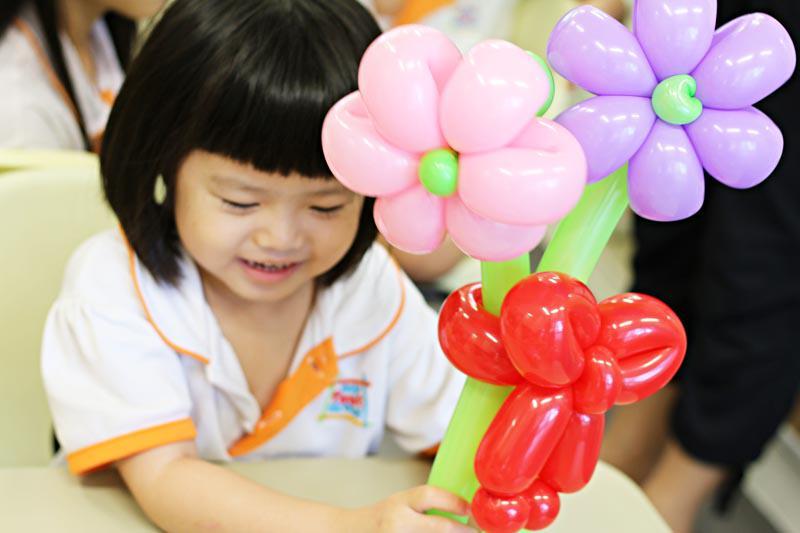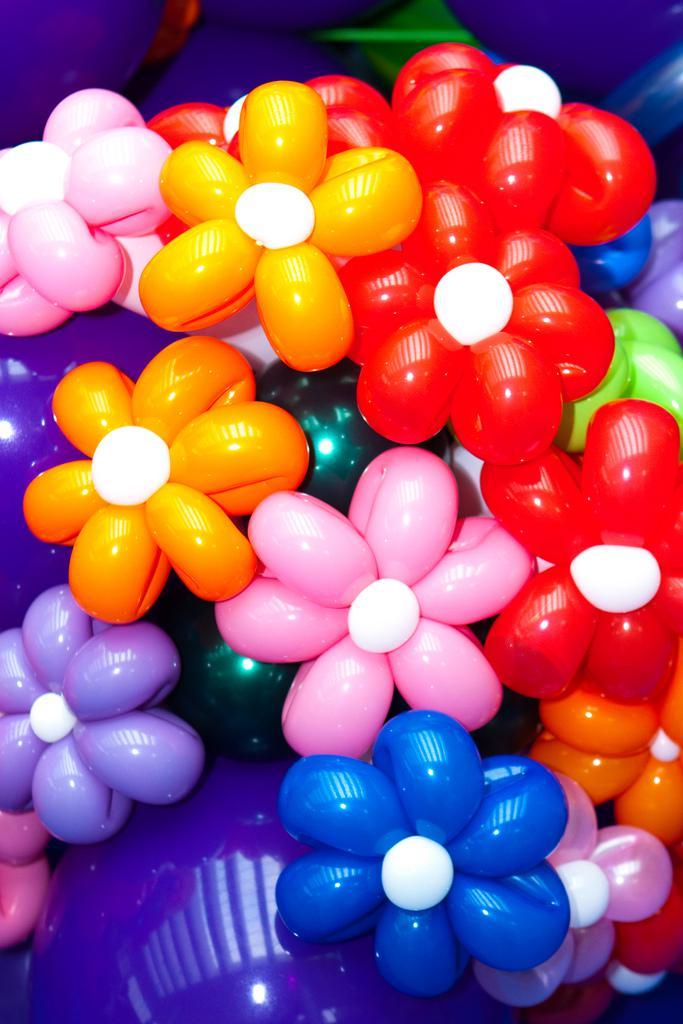The first image is the image on the left, the second image is the image on the right. Given the left and right images, does the statement "One of the balloons is shaped like spiderman." hold true? Answer yes or no. No. 